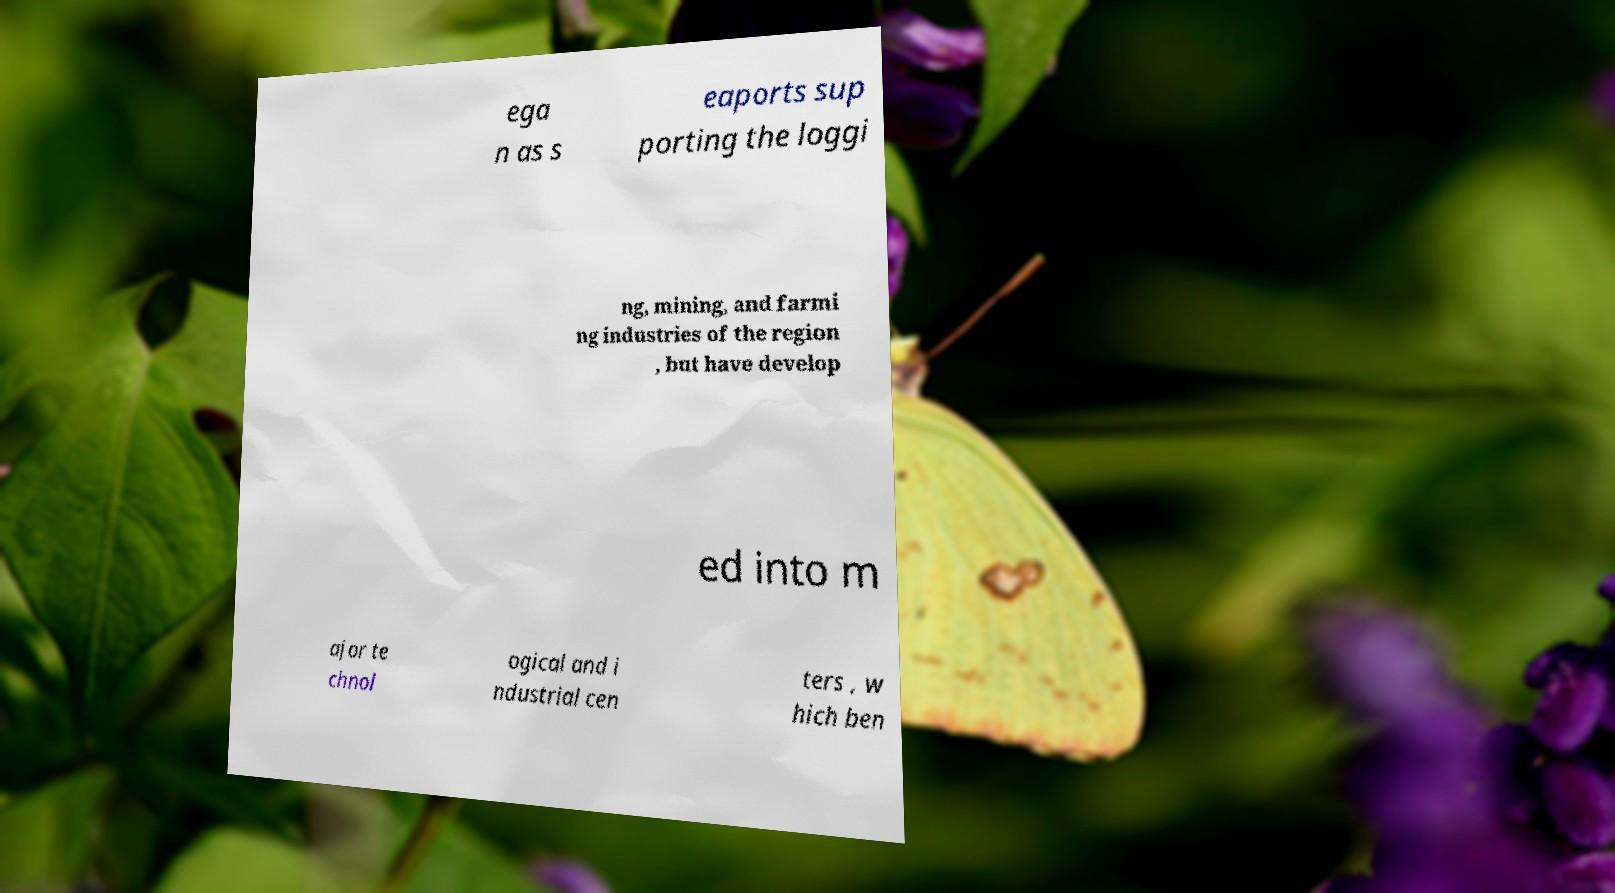I need the written content from this picture converted into text. Can you do that? ega n as s eaports sup porting the loggi ng, mining, and farmi ng industries of the region , but have develop ed into m ajor te chnol ogical and i ndustrial cen ters , w hich ben 